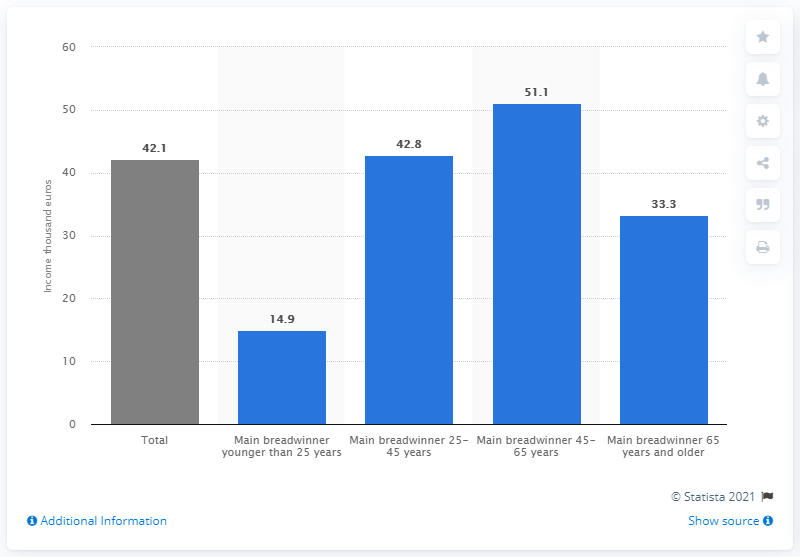Indicate a few pertinent items in this graphic. The sum of the highest and lowest value of the blue bars is 66. The value for the main breadwinner who is 65 years or older is 33.3%. 